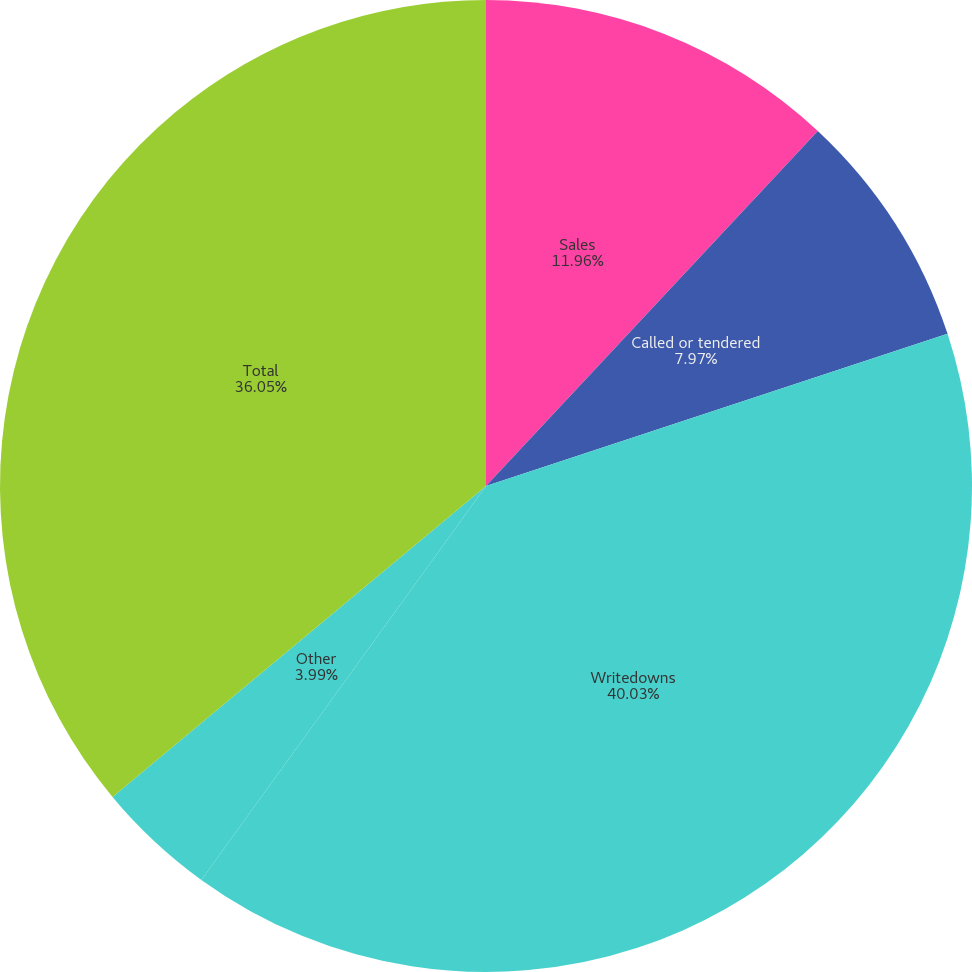<chart> <loc_0><loc_0><loc_500><loc_500><pie_chart><fcel>Sales<fcel>Called or tendered<fcel>Writedowns<fcel>Loss on redemption of debt<fcel>Other<fcel>Total<nl><fcel>11.96%<fcel>7.97%<fcel>40.03%<fcel>0.0%<fcel>3.99%<fcel>36.05%<nl></chart> 